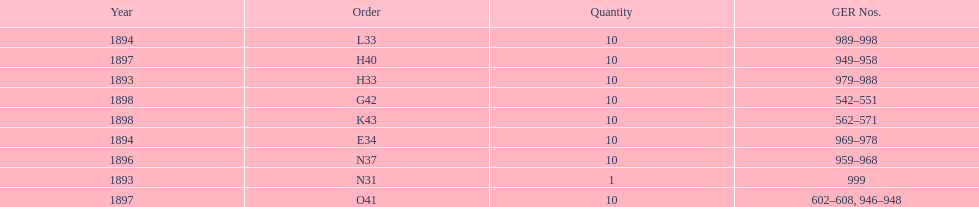When was g42, 1898 or 1894? 1898. 